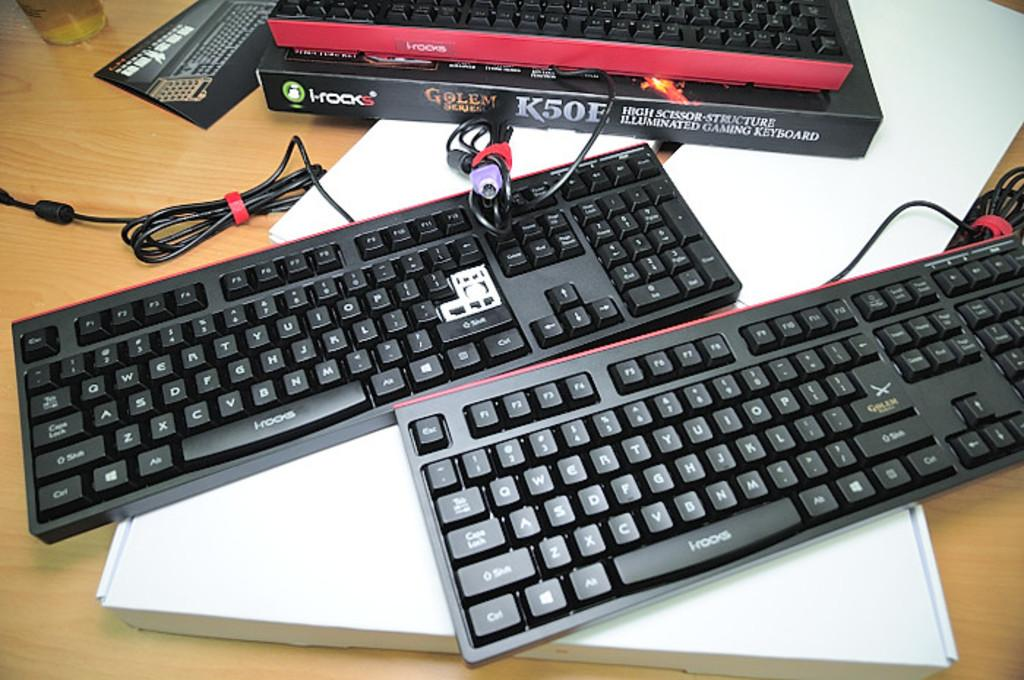What type of electronic devices can be seen in the image? There are keyboards in the image. What other objects are present on the table in the image? There are boxes, wires, a paper, and a glass in the image. How are the keyboards connected to each other or other devices? The wires in the image suggest that the keyboards may be connected to other devices. What might be used for drinking in the image? There is a glass in the image that could be used for drinking. What type of trains can be seen passing through downtown in the image? There are no trains or downtown area depicted in the image; it features keyboards, boxes, wires, a paper, and a glass on a table. How many babies are visible in the image? There are no babies present in the image. 